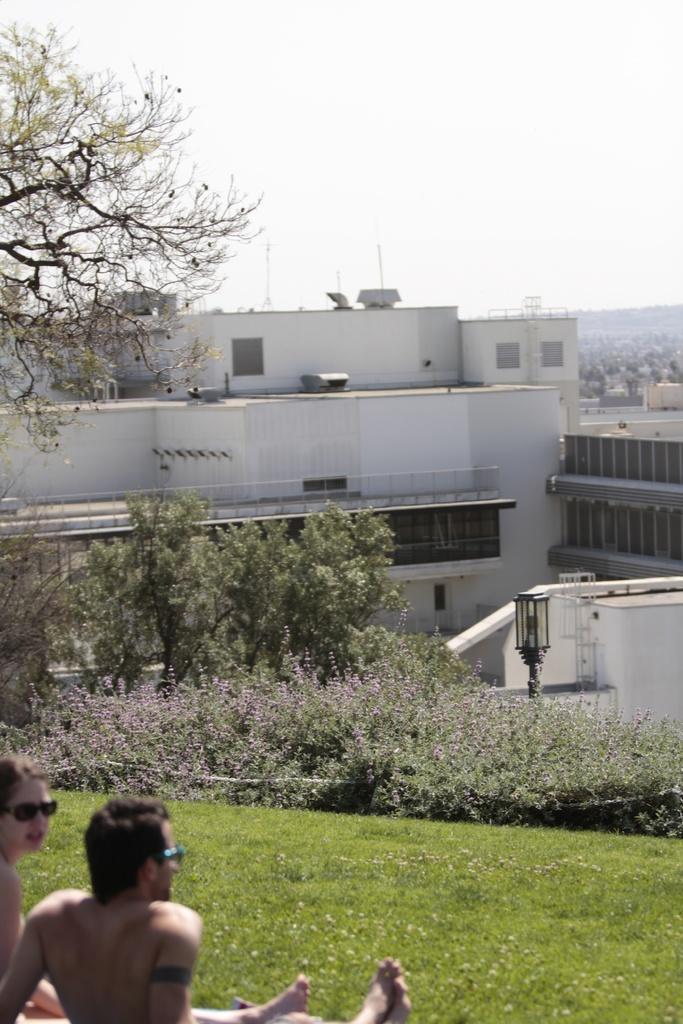Please provide a concise description of this image. This image is taken outdoors. At the top of the image there is the sky. At the bottom of the image there is a ground with grass on it. A man and a woman are sitting on the ground. In the middle of the image there are many buildings. There are a few trees and plants. There is a pole with a street light. 